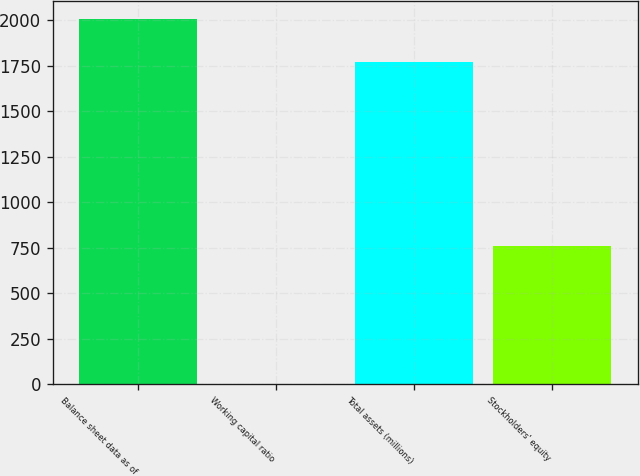<chart> <loc_0><loc_0><loc_500><loc_500><bar_chart><fcel>Balance sheet data as of<fcel>Working capital ratio<fcel>Total assets (millions)<fcel>Stockholders' equity<nl><fcel>2006<fcel>0.98<fcel>1770<fcel>759<nl></chart> 